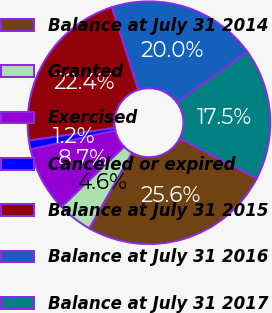<chart> <loc_0><loc_0><loc_500><loc_500><pie_chart><fcel>Balance at July 31 2014<fcel>Granted<fcel>Exercised<fcel>Canceled or expired<fcel>Balance at July 31 2015<fcel>Balance at July 31 2016<fcel>Balance at July 31 2017<nl><fcel>25.6%<fcel>4.64%<fcel>8.67%<fcel>1.18%<fcel>22.41%<fcel>19.97%<fcel>17.53%<nl></chart> 